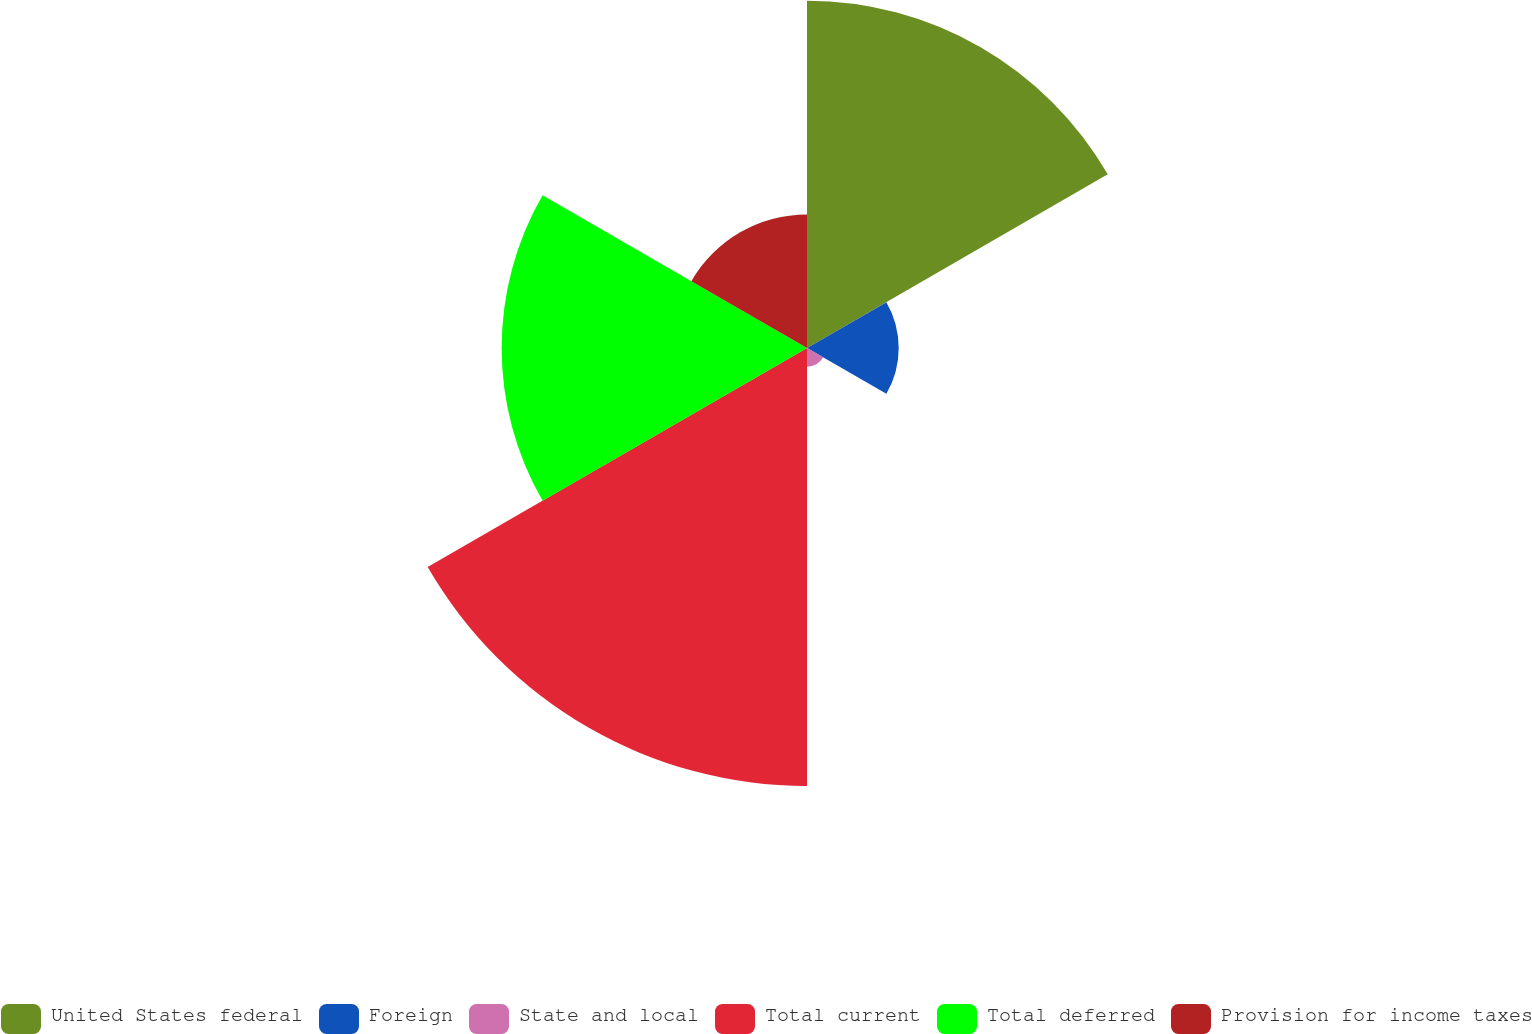<chart> <loc_0><loc_0><loc_500><loc_500><pie_chart><fcel>United States federal<fcel>Foreign<fcel>State and local<fcel>Total current<fcel>Total deferred<fcel>Provision for income taxes<nl><fcel>26.02%<fcel>6.87%<fcel>1.4%<fcel>32.82%<fcel>22.88%<fcel>10.01%<nl></chart> 